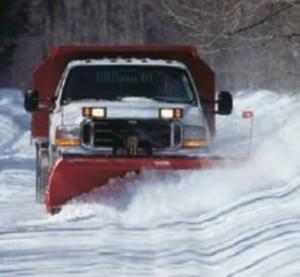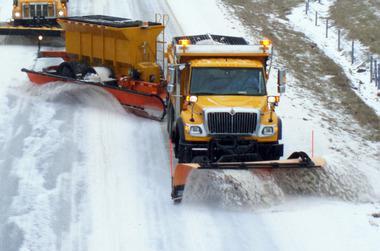The first image is the image on the left, the second image is the image on the right. Evaluate the accuracy of this statement regarding the images: "there is at least one red truck in the image". Is it true? Answer yes or no. No. 